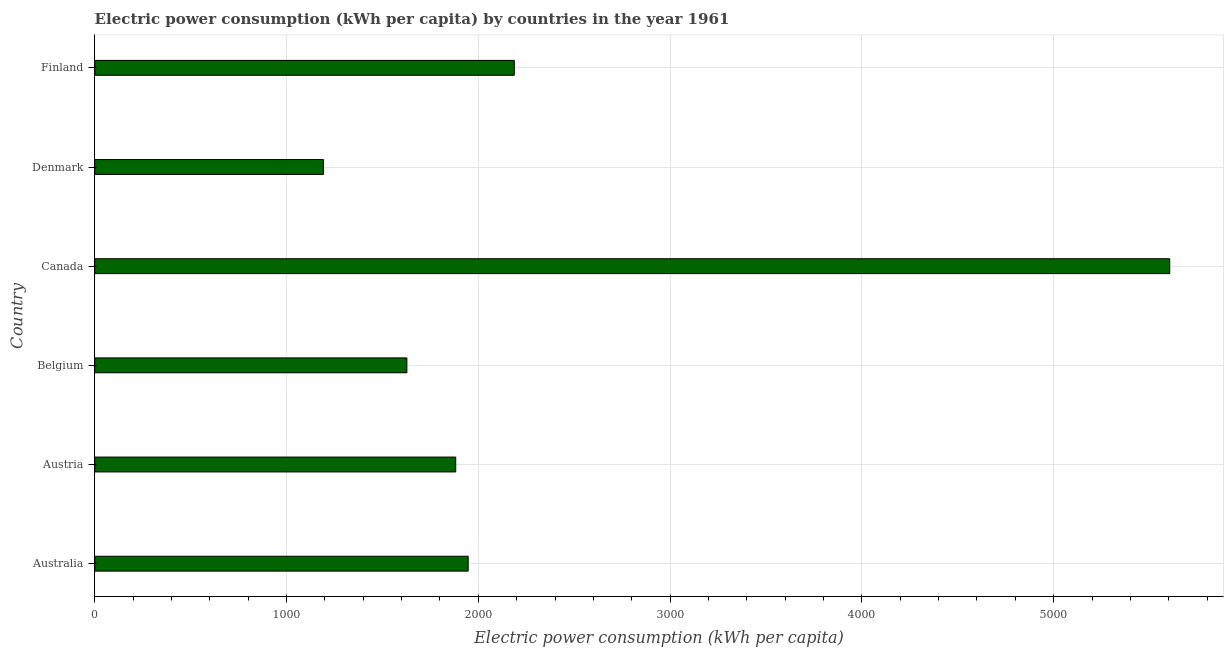Does the graph contain any zero values?
Provide a short and direct response. No. What is the title of the graph?
Make the answer very short. Electric power consumption (kWh per capita) by countries in the year 1961. What is the label or title of the X-axis?
Offer a very short reply. Electric power consumption (kWh per capita). What is the label or title of the Y-axis?
Offer a very short reply. Country. What is the electric power consumption in Belgium?
Give a very brief answer. 1627.51. Across all countries, what is the maximum electric power consumption?
Offer a terse response. 5605.11. Across all countries, what is the minimum electric power consumption?
Keep it short and to the point. 1192.41. In which country was the electric power consumption maximum?
Your response must be concise. Canada. What is the sum of the electric power consumption?
Your answer should be compact. 1.44e+04. What is the difference between the electric power consumption in Austria and Denmark?
Ensure brevity in your answer.  689.82. What is the average electric power consumption per country?
Keep it short and to the point. 2407.01. What is the median electric power consumption?
Provide a short and direct response. 1914.69. In how many countries, is the electric power consumption greater than 3000 kWh per capita?
Make the answer very short. 1. What is the ratio of the electric power consumption in Austria to that in Finland?
Keep it short and to the point. 0.86. Is the electric power consumption in Austria less than that in Canada?
Give a very brief answer. Yes. Is the difference between the electric power consumption in Australia and Denmark greater than the difference between any two countries?
Offer a terse response. No. What is the difference between the highest and the second highest electric power consumption?
Provide a short and direct response. 3417.49. What is the difference between the highest and the lowest electric power consumption?
Offer a very short reply. 4412.71. How many bars are there?
Your response must be concise. 6. How many countries are there in the graph?
Give a very brief answer. 6. What is the difference between two consecutive major ticks on the X-axis?
Give a very brief answer. 1000. What is the Electric power consumption (kWh per capita) in Australia?
Provide a short and direct response. 1947.15. What is the Electric power consumption (kWh per capita) in Austria?
Provide a succinct answer. 1882.22. What is the Electric power consumption (kWh per capita) in Belgium?
Make the answer very short. 1627.51. What is the Electric power consumption (kWh per capita) of Canada?
Offer a very short reply. 5605.11. What is the Electric power consumption (kWh per capita) in Denmark?
Your answer should be compact. 1192.41. What is the Electric power consumption (kWh per capita) in Finland?
Give a very brief answer. 2187.62. What is the difference between the Electric power consumption (kWh per capita) in Australia and Austria?
Give a very brief answer. 64.93. What is the difference between the Electric power consumption (kWh per capita) in Australia and Belgium?
Your answer should be compact. 319.64. What is the difference between the Electric power consumption (kWh per capita) in Australia and Canada?
Ensure brevity in your answer.  -3657.96. What is the difference between the Electric power consumption (kWh per capita) in Australia and Denmark?
Provide a short and direct response. 754.75. What is the difference between the Electric power consumption (kWh per capita) in Australia and Finland?
Your answer should be compact. -240.47. What is the difference between the Electric power consumption (kWh per capita) in Austria and Belgium?
Provide a succinct answer. 254.71. What is the difference between the Electric power consumption (kWh per capita) in Austria and Canada?
Offer a terse response. -3722.89. What is the difference between the Electric power consumption (kWh per capita) in Austria and Denmark?
Offer a terse response. 689.82. What is the difference between the Electric power consumption (kWh per capita) in Austria and Finland?
Offer a terse response. -305.4. What is the difference between the Electric power consumption (kWh per capita) in Belgium and Canada?
Offer a very short reply. -3977.6. What is the difference between the Electric power consumption (kWh per capita) in Belgium and Denmark?
Offer a terse response. 435.11. What is the difference between the Electric power consumption (kWh per capita) in Belgium and Finland?
Your response must be concise. -560.11. What is the difference between the Electric power consumption (kWh per capita) in Canada and Denmark?
Your response must be concise. 4412.71. What is the difference between the Electric power consumption (kWh per capita) in Canada and Finland?
Your answer should be very brief. 3417.49. What is the difference between the Electric power consumption (kWh per capita) in Denmark and Finland?
Ensure brevity in your answer.  -995.22. What is the ratio of the Electric power consumption (kWh per capita) in Australia to that in Austria?
Provide a succinct answer. 1.03. What is the ratio of the Electric power consumption (kWh per capita) in Australia to that in Belgium?
Ensure brevity in your answer.  1.2. What is the ratio of the Electric power consumption (kWh per capita) in Australia to that in Canada?
Give a very brief answer. 0.35. What is the ratio of the Electric power consumption (kWh per capita) in Australia to that in Denmark?
Your answer should be very brief. 1.63. What is the ratio of the Electric power consumption (kWh per capita) in Australia to that in Finland?
Provide a succinct answer. 0.89. What is the ratio of the Electric power consumption (kWh per capita) in Austria to that in Belgium?
Your answer should be compact. 1.16. What is the ratio of the Electric power consumption (kWh per capita) in Austria to that in Canada?
Your answer should be very brief. 0.34. What is the ratio of the Electric power consumption (kWh per capita) in Austria to that in Denmark?
Offer a terse response. 1.58. What is the ratio of the Electric power consumption (kWh per capita) in Austria to that in Finland?
Make the answer very short. 0.86. What is the ratio of the Electric power consumption (kWh per capita) in Belgium to that in Canada?
Your answer should be compact. 0.29. What is the ratio of the Electric power consumption (kWh per capita) in Belgium to that in Denmark?
Ensure brevity in your answer.  1.36. What is the ratio of the Electric power consumption (kWh per capita) in Belgium to that in Finland?
Your answer should be compact. 0.74. What is the ratio of the Electric power consumption (kWh per capita) in Canada to that in Denmark?
Provide a succinct answer. 4.7. What is the ratio of the Electric power consumption (kWh per capita) in Canada to that in Finland?
Your response must be concise. 2.56. What is the ratio of the Electric power consumption (kWh per capita) in Denmark to that in Finland?
Give a very brief answer. 0.55. 